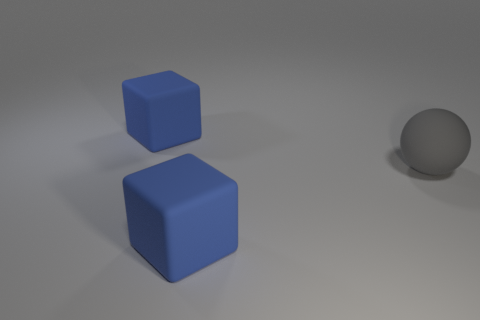How many blue things are in front of the big sphere and behind the gray object?
Make the answer very short. 0. What is the size of the sphere?
Your response must be concise. Large. What is the large gray ball made of?
Give a very brief answer. Rubber. There is a matte thing that is behind the ball; is it the same size as the sphere?
Your answer should be very brief. Yes. How many things are large gray rubber balls or big blue cubes?
Your response must be concise. 3. How many large gray matte things are there?
Offer a very short reply. 1. How many balls are either matte things or large gray objects?
Make the answer very short. 1. What number of large blue rubber objects are on the right side of the large blue thing that is in front of the big blue rubber thing behind the gray rubber ball?
Offer a terse response. 0. What number of other objects are the same color as the big matte ball?
Make the answer very short. 0. Are there more rubber things that are on the right side of the large rubber sphere than blue rubber objects?
Ensure brevity in your answer.  No. 